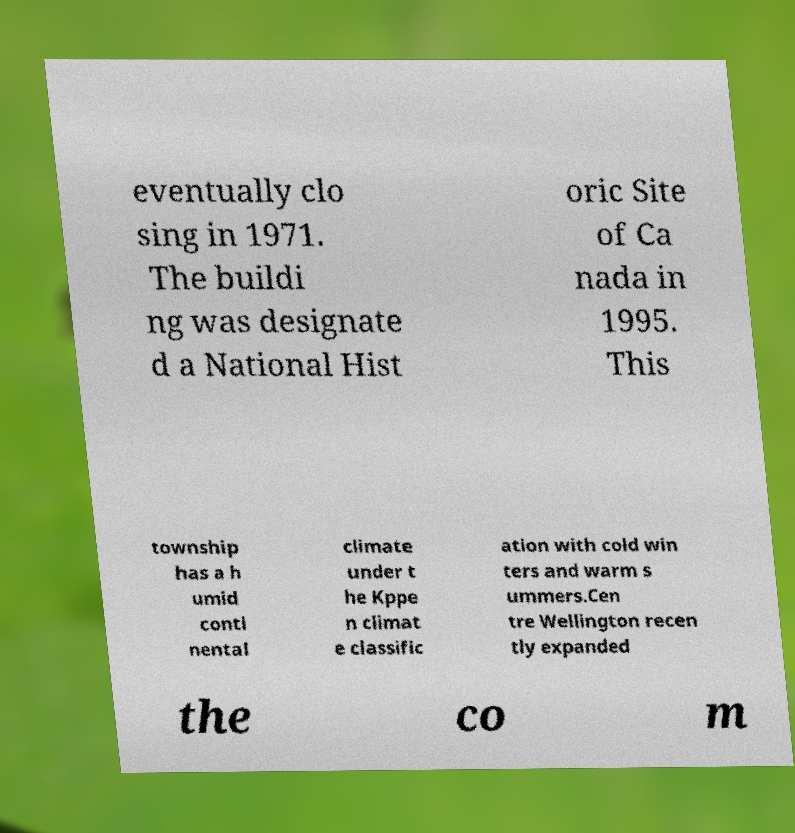What messages or text are displayed in this image? I need them in a readable, typed format. eventually clo sing in 1971. The buildi ng was designate d a National Hist oric Site of Ca nada in 1995. This township has a h umid conti nental climate under t he Kppe n climat e classific ation with cold win ters and warm s ummers.Cen tre Wellington recen tly expanded the co m 